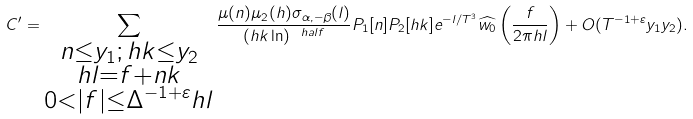<formula> <loc_0><loc_0><loc_500><loc_500>C ^ { \prime } = \sum _ { \substack { n \leq y _ { 1 } ; \, h k \leq y _ { 2 } \\ h l = f + n k \\ 0 < | f | \leq \Delta ^ { - 1 + \varepsilon } h l } } \frac { \mu ( n ) \mu _ { 2 } ( h ) \sigma _ { \alpha , - \beta } ( l ) } { ( h k \ln ) ^ { \ h a l f } } P _ { 1 } [ n ] P _ { 2 } [ h k ] e ^ { - l / T ^ { 3 } } \widehat { w _ { 0 } } \left ( \frac { f } { 2 \pi h l } \right ) + O ( T ^ { - 1 + \varepsilon } y _ { 1 } y _ { 2 } ) .</formula> 